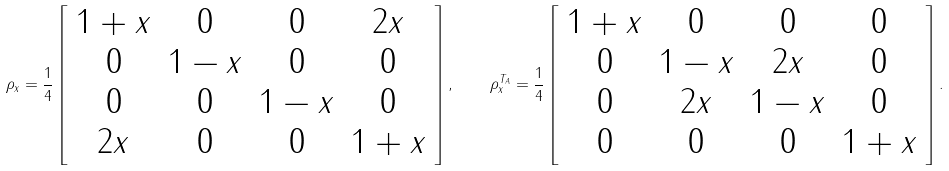Convert formula to latex. <formula><loc_0><loc_0><loc_500><loc_500>\rho _ { x } = \frac { 1 } { 4 } \left [ \begin{array} { c c c c } 1 + x & 0 & 0 & 2 x \\ 0 & 1 - x & 0 & 0 \\ 0 & 0 & 1 - x & 0 \\ 2 x & 0 & 0 & 1 + x \end{array} \right ] , \quad \rho _ { x } ^ { T _ { A } } = \frac { 1 } { 4 } \left [ \begin{array} { c c c c } 1 + x & 0 & 0 & 0 \\ 0 & 1 - x & 2 x & 0 \\ 0 & 2 x & 1 - x & 0 \\ 0 & 0 & 0 & 1 + x \end{array} \right ] .</formula> 